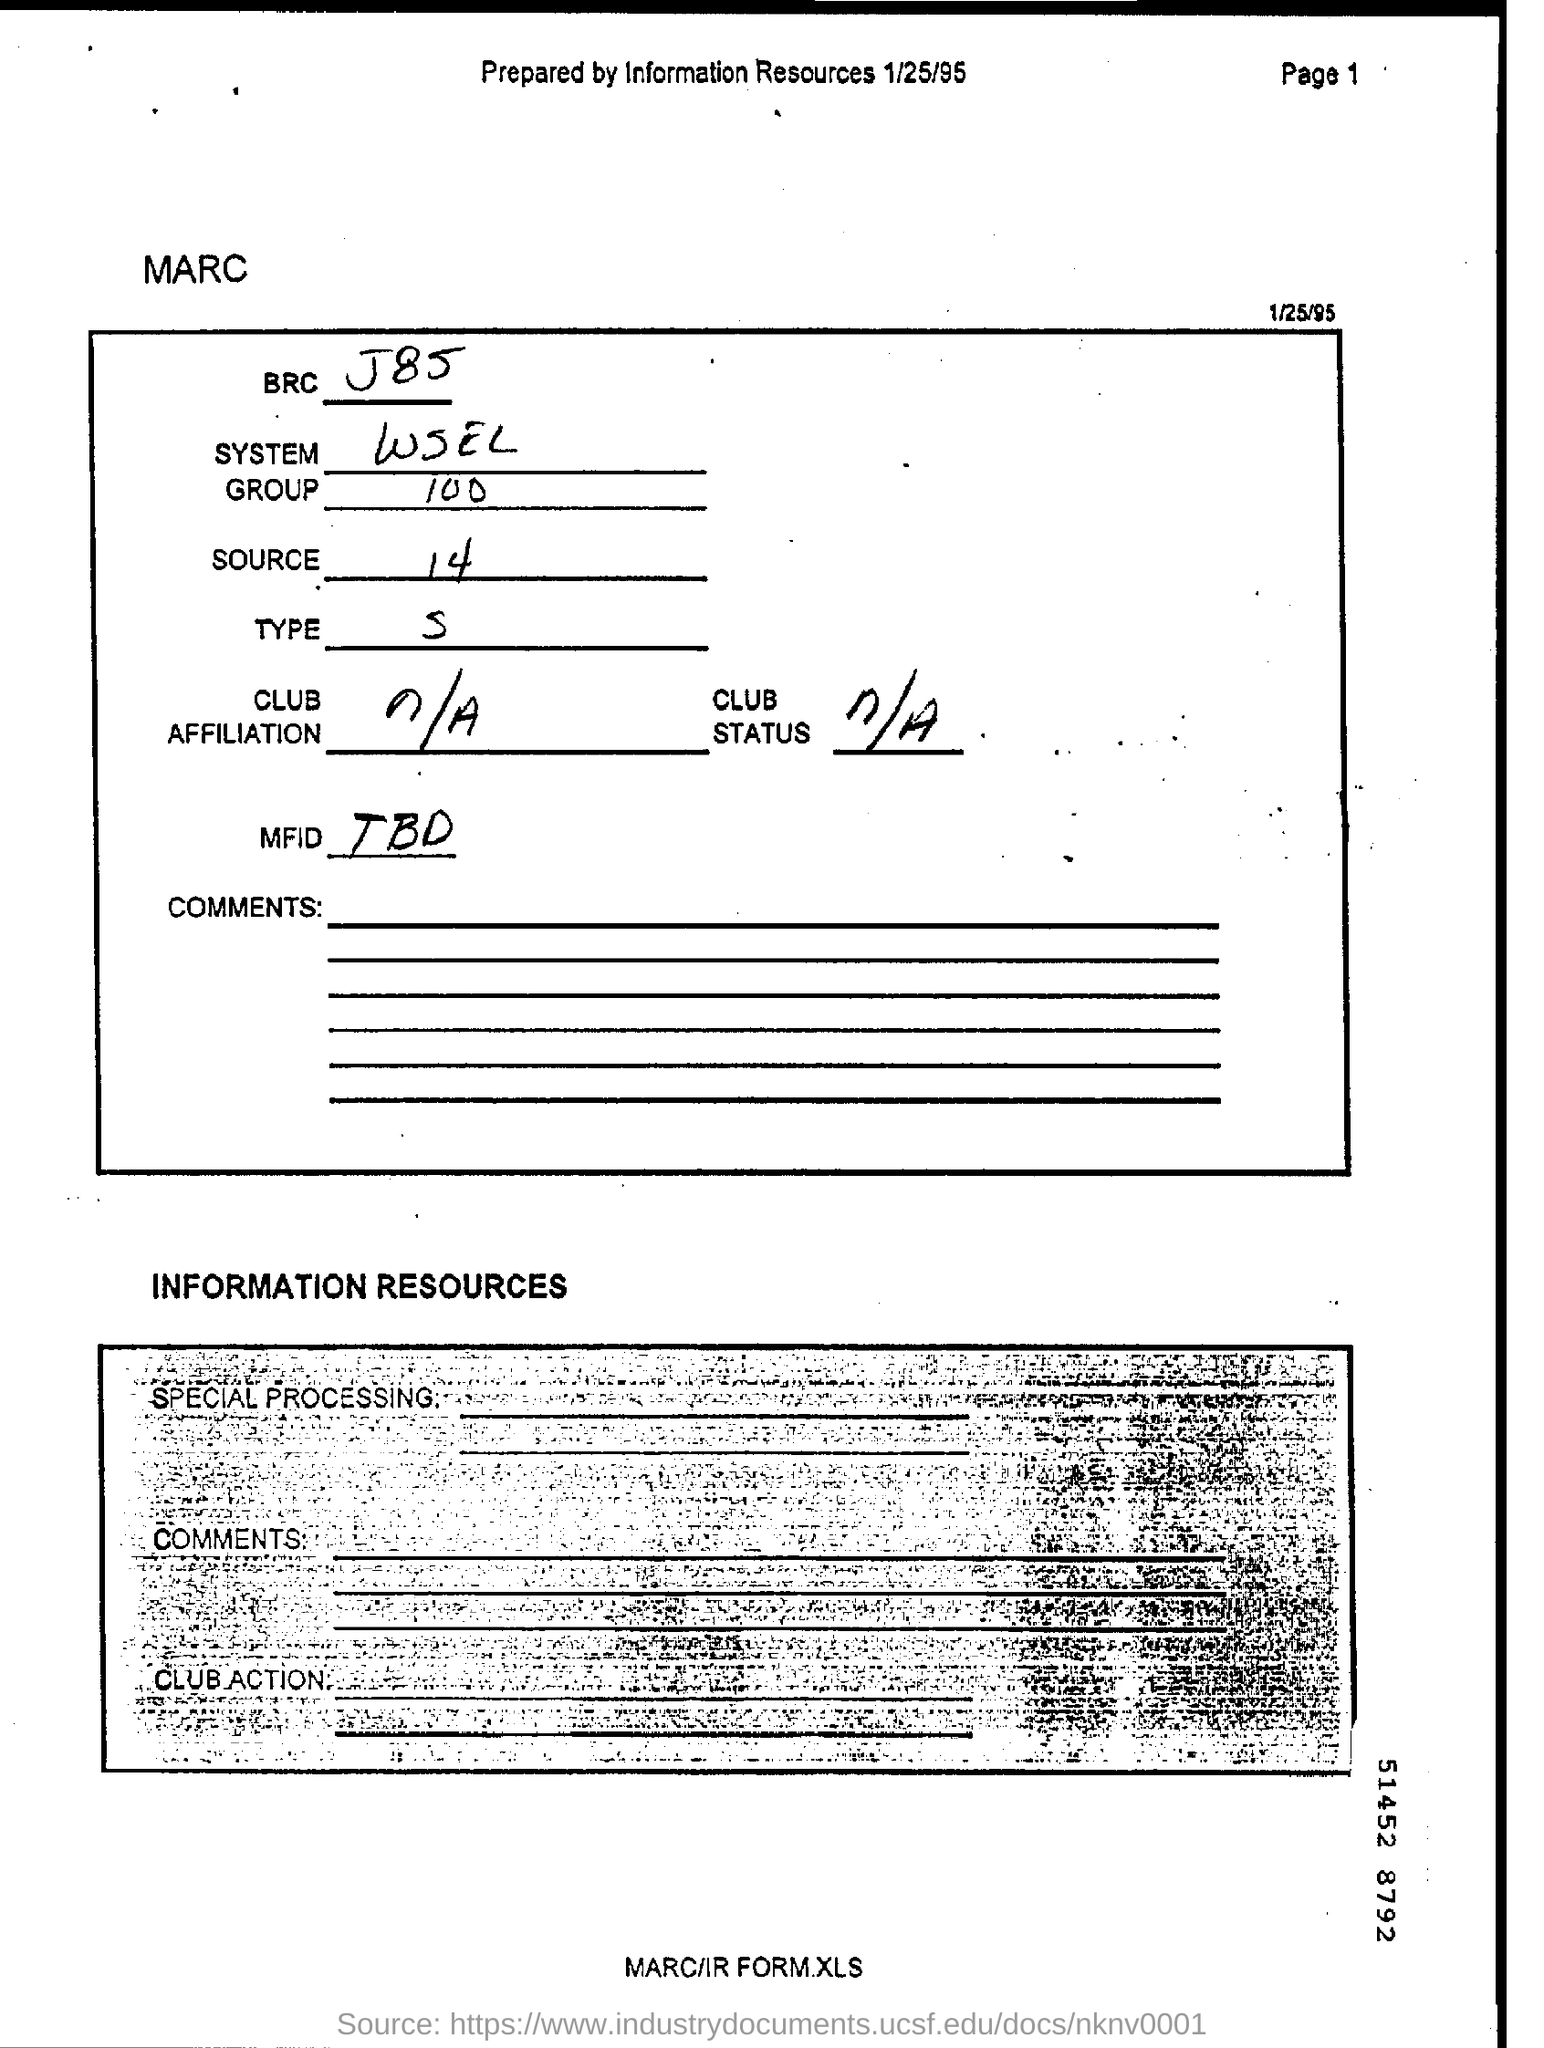List a handful of essential elements in this visual. The group is comprised of 100 individuals. The date on the document is January 25, 1995. The System, which is represented by the acronym WSEL, is a complex and multifaceted entity that is difficult to fully comprehend. 